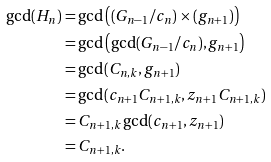Convert formula to latex. <formula><loc_0><loc_0><loc_500><loc_500>\gcd ( H _ { n } ) & = \gcd \left ( ( G _ { n - 1 } / c _ { n } ) \times ( g _ { n + 1 } ) \right ) \\ & = \gcd \left ( \gcd ( G _ { n - 1 } / c _ { n } ) , g _ { n + 1 } \right ) \\ & = \gcd ( C _ { n , k } , g _ { n + 1 } ) \\ & = \gcd ( c _ { n + 1 } C _ { n + 1 , k } , z _ { n + 1 } C _ { n + 1 , k } ) \\ & = C _ { n + 1 , k } \gcd ( c _ { n + 1 } , z _ { n + 1 } ) \\ & = C _ { n + 1 , k } .</formula> 